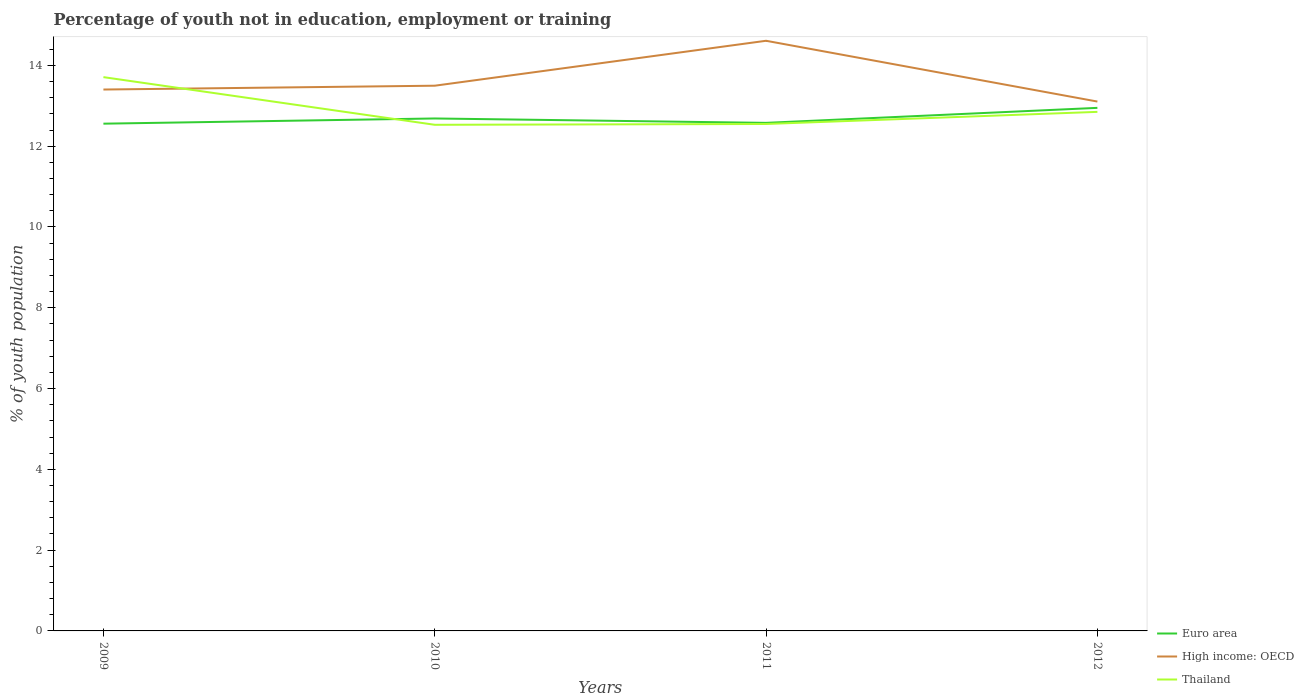Is the number of lines equal to the number of legend labels?
Keep it short and to the point. Yes. Across all years, what is the maximum percentage of unemployed youth population in in High income: OECD?
Your answer should be compact. 13.11. What is the total percentage of unemployed youth population in in High income: OECD in the graph?
Offer a terse response. 0.39. What is the difference between the highest and the second highest percentage of unemployed youth population in in High income: OECD?
Provide a succinct answer. 1.5. What is the difference between the highest and the lowest percentage of unemployed youth population in in Euro area?
Give a very brief answer. 1. How many lines are there?
Your answer should be compact. 3. Are the values on the major ticks of Y-axis written in scientific E-notation?
Provide a succinct answer. No. Does the graph contain grids?
Give a very brief answer. No. Where does the legend appear in the graph?
Your answer should be compact. Bottom right. What is the title of the graph?
Ensure brevity in your answer.  Percentage of youth not in education, employment or training. Does "Mali" appear as one of the legend labels in the graph?
Give a very brief answer. No. What is the label or title of the X-axis?
Your answer should be compact. Years. What is the label or title of the Y-axis?
Ensure brevity in your answer.  % of youth population. What is the % of youth population in Euro area in 2009?
Your response must be concise. 12.56. What is the % of youth population of High income: OECD in 2009?
Provide a short and direct response. 13.4. What is the % of youth population in Thailand in 2009?
Offer a very short reply. 13.71. What is the % of youth population of Euro area in 2010?
Make the answer very short. 12.69. What is the % of youth population of High income: OECD in 2010?
Offer a very short reply. 13.5. What is the % of youth population of Thailand in 2010?
Keep it short and to the point. 12.53. What is the % of youth population in Euro area in 2011?
Provide a short and direct response. 12.58. What is the % of youth population of High income: OECD in 2011?
Make the answer very short. 14.61. What is the % of youth population of Thailand in 2011?
Your response must be concise. 12.55. What is the % of youth population in Euro area in 2012?
Offer a terse response. 12.95. What is the % of youth population in High income: OECD in 2012?
Give a very brief answer. 13.11. What is the % of youth population in Thailand in 2012?
Offer a very short reply. 12.85. Across all years, what is the maximum % of youth population in Euro area?
Ensure brevity in your answer.  12.95. Across all years, what is the maximum % of youth population in High income: OECD?
Offer a very short reply. 14.61. Across all years, what is the maximum % of youth population in Thailand?
Make the answer very short. 13.71. Across all years, what is the minimum % of youth population in Euro area?
Offer a very short reply. 12.56. Across all years, what is the minimum % of youth population in High income: OECD?
Provide a succinct answer. 13.11. Across all years, what is the minimum % of youth population in Thailand?
Your response must be concise. 12.53. What is the total % of youth population of Euro area in the graph?
Offer a very short reply. 50.77. What is the total % of youth population of High income: OECD in the graph?
Offer a terse response. 54.62. What is the total % of youth population of Thailand in the graph?
Provide a short and direct response. 51.64. What is the difference between the % of youth population in Euro area in 2009 and that in 2010?
Offer a terse response. -0.13. What is the difference between the % of youth population in High income: OECD in 2009 and that in 2010?
Provide a succinct answer. -0.09. What is the difference between the % of youth population in Thailand in 2009 and that in 2010?
Your answer should be very brief. 1.18. What is the difference between the % of youth population of Euro area in 2009 and that in 2011?
Provide a succinct answer. -0.02. What is the difference between the % of youth population of High income: OECD in 2009 and that in 2011?
Keep it short and to the point. -1.21. What is the difference between the % of youth population of Thailand in 2009 and that in 2011?
Your answer should be very brief. 1.16. What is the difference between the % of youth population in Euro area in 2009 and that in 2012?
Make the answer very short. -0.39. What is the difference between the % of youth population in High income: OECD in 2009 and that in 2012?
Offer a very short reply. 0.3. What is the difference between the % of youth population in Thailand in 2009 and that in 2012?
Provide a succinct answer. 0.86. What is the difference between the % of youth population in Euro area in 2010 and that in 2011?
Your answer should be very brief. 0.11. What is the difference between the % of youth population in High income: OECD in 2010 and that in 2011?
Offer a terse response. -1.11. What is the difference between the % of youth population in Thailand in 2010 and that in 2011?
Offer a terse response. -0.02. What is the difference between the % of youth population in Euro area in 2010 and that in 2012?
Provide a short and direct response. -0.26. What is the difference between the % of youth population in High income: OECD in 2010 and that in 2012?
Give a very brief answer. 0.39. What is the difference between the % of youth population in Thailand in 2010 and that in 2012?
Provide a short and direct response. -0.32. What is the difference between the % of youth population of Euro area in 2011 and that in 2012?
Provide a short and direct response. -0.37. What is the difference between the % of youth population of High income: OECD in 2011 and that in 2012?
Make the answer very short. 1.5. What is the difference between the % of youth population of Thailand in 2011 and that in 2012?
Offer a terse response. -0.3. What is the difference between the % of youth population in Euro area in 2009 and the % of youth population in High income: OECD in 2010?
Make the answer very short. -0.94. What is the difference between the % of youth population in Euro area in 2009 and the % of youth population in Thailand in 2010?
Offer a very short reply. 0.03. What is the difference between the % of youth population in High income: OECD in 2009 and the % of youth population in Thailand in 2010?
Your answer should be very brief. 0.87. What is the difference between the % of youth population in Euro area in 2009 and the % of youth population in High income: OECD in 2011?
Your answer should be very brief. -2.05. What is the difference between the % of youth population in Euro area in 2009 and the % of youth population in Thailand in 2011?
Your response must be concise. 0.01. What is the difference between the % of youth population in High income: OECD in 2009 and the % of youth population in Thailand in 2011?
Give a very brief answer. 0.85. What is the difference between the % of youth population in Euro area in 2009 and the % of youth population in High income: OECD in 2012?
Give a very brief answer. -0.55. What is the difference between the % of youth population of Euro area in 2009 and the % of youth population of Thailand in 2012?
Ensure brevity in your answer.  -0.29. What is the difference between the % of youth population of High income: OECD in 2009 and the % of youth population of Thailand in 2012?
Provide a succinct answer. 0.55. What is the difference between the % of youth population in Euro area in 2010 and the % of youth population in High income: OECD in 2011?
Your answer should be very brief. -1.92. What is the difference between the % of youth population in Euro area in 2010 and the % of youth population in Thailand in 2011?
Keep it short and to the point. 0.14. What is the difference between the % of youth population of High income: OECD in 2010 and the % of youth population of Thailand in 2011?
Offer a terse response. 0.95. What is the difference between the % of youth population in Euro area in 2010 and the % of youth population in High income: OECD in 2012?
Your response must be concise. -0.42. What is the difference between the % of youth population in Euro area in 2010 and the % of youth population in Thailand in 2012?
Offer a very short reply. -0.16. What is the difference between the % of youth population in High income: OECD in 2010 and the % of youth population in Thailand in 2012?
Give a very brief answer. 0.65. What is the difference between the % of youth population in Euro area in 2011 and the % of youth population in High income: OECD in 2012?
Offer a very short reply. -0.53. What is the difference between the % of youth population of Euro area in 2011 and the % of youth population of Thailand in 2012?
Give a very brief answer. -0.27. What is the difference between the % of youth population in High income: OECD in 2011 and the % of youth population in Thailand in 2012?
Provide a short and direct response. 1.76. What is the average % of youth population in Euro area per year?
Keep it short and to the point. 12.69. What is the average % of youth population of High income: OECD per year?
Make the answer very short. 13.65. What is the average % of youth population of Thailand per year?
Offer a terse response. 12.91. In the year 2009, what is the difference between the % of youth population in Euro area and % of youth population in High income: OECD?
Keep it short and to the point. -0.85. In the year 2009, what is the difference between the % of youth population of Euro area and % of youth population of Thailand?
Provide a succinct answer. -1.15. In the year 2009, what is the difference between the % of youth population of High income: OECD and % of youth population of Thailand?
Make the answer very short. -0.31. In the year 2010, what is the difference between the % of youth population in Euro area and % of youth population in High income: OECD?
Your answer should be very brief. -0.81. In the year 2010, what is the difference between the % of youth population in Euro area and % of youth population in Thailand?
Offer a very short reply. 0.16. In the year 2010, what is the difference between the % of youth population of High income: OECD and % of youth population of Thailand?
Keep it short and to the point. 0.97. In the year 2011, what is the difference between the % of youth population in Euro area and % of youth population in High income: OECD?
Offer a terse response. -2.03. In the year 2011, what is the difference between the % of youth population in Euro area and % of youth population in Thailand?
Keep it short and to the point. 0.03. In the year 2011, what is the difference between the % of youth population in High income: OECD and % of youth population in Thailand?
Offer a very short reply. 2.06. In the year 2012, what is the difference between the % of youth population in Euro area and % of youth population in High income: OECD?
Keep it short and to the point. -0.16. In the year 2012, what is the difference between the % of youth population in Euro area and % of youth population in Thailand?
Provide a short and direct response. 0.1. In the year 2012, what is the difference between the % of youth population in High income: OECD and % of youth population in Thailand?
Offer a terse response. 0.26. What is the ratio of the % of youth population in Thailand in 2009 to that in 2010?
Give a very brief answer. 1.09. What is the ratio of the % of youth population in High income: OECD in 2009 to that in 2011?
Ensure brevity in your answer.  0.92. What is the ratio of the % of youth population of Thailand in 2009 to that in 2011?
Give a very brief answer. 1.09. What is the ratio of the % of youth population in Euro area in 2009 to that in 2012?
Provide a short and direct response. 0.97. What is the ratio of the % of youth population in High income: OECD in 2009 to that in 2012?
Make the answer very short. 1.02. What is the ratio of the % of youth population in Thailand in 2009 to that in 2012?
Keep it short and to the point. 1.07. What is the ratio of the % of youth population of Euro area in 2010 to that in 2011?
Make the answer very short. 1.01. What is the ratio of the % of youth population in High income: OECD in 2010 to that in 2011?
Your answer should be very brief. 0.92. What is the ratio of the % of youth population in Thailand in 2010 to that in 2011?
Give a very brief answer. 1. What is the ratio of the % of youth population in Euro area in 2010 to that in 2012?
Your answer should be compact. 0.98. What is the ratio of the % of youth population in High income: OECD in 2010 to that in 2012?
Your response must be concise. 1.03. What is the ratio of the % of youth population of Thailand in 2010 to that in 2012?
Your answer should be very brief. 0.98. What is the ratio of the % of youth population of Euro area in 2011 to that in 2012?
Your response must be concise. 0.97. What is the ratio of the % of youth population of High income: OECD in 2011 to that in 2012?
Offer a terse response. 1.11. What is the ratio of the % of youth population of Thailand in 2011 to that in 2012?
Give a very brief answer. 0.98. What is the difference between the highest and the second highest % of youth population in Euro area?
Your answer should be very brief. 0.26. What is the difference between the highest and the second highest % of youth population in High income: OECD?
Ensure brevity in your answer.  1.11. What is the difference between the highest and the second highest % of youth population of Thailand?
Your response must be concise. 0.86. What is the difference between the highest and the lowest % of youth population of Euro area?
Your answer should be compact. 0.39. What is the difference between the highest and the lowest % of youth population in High income: OECD?
Make the answer very short. 1.5. What is the difference between the highest and the lowest % of youth population of Thailand?
Offer a very short reply. 1.18. 